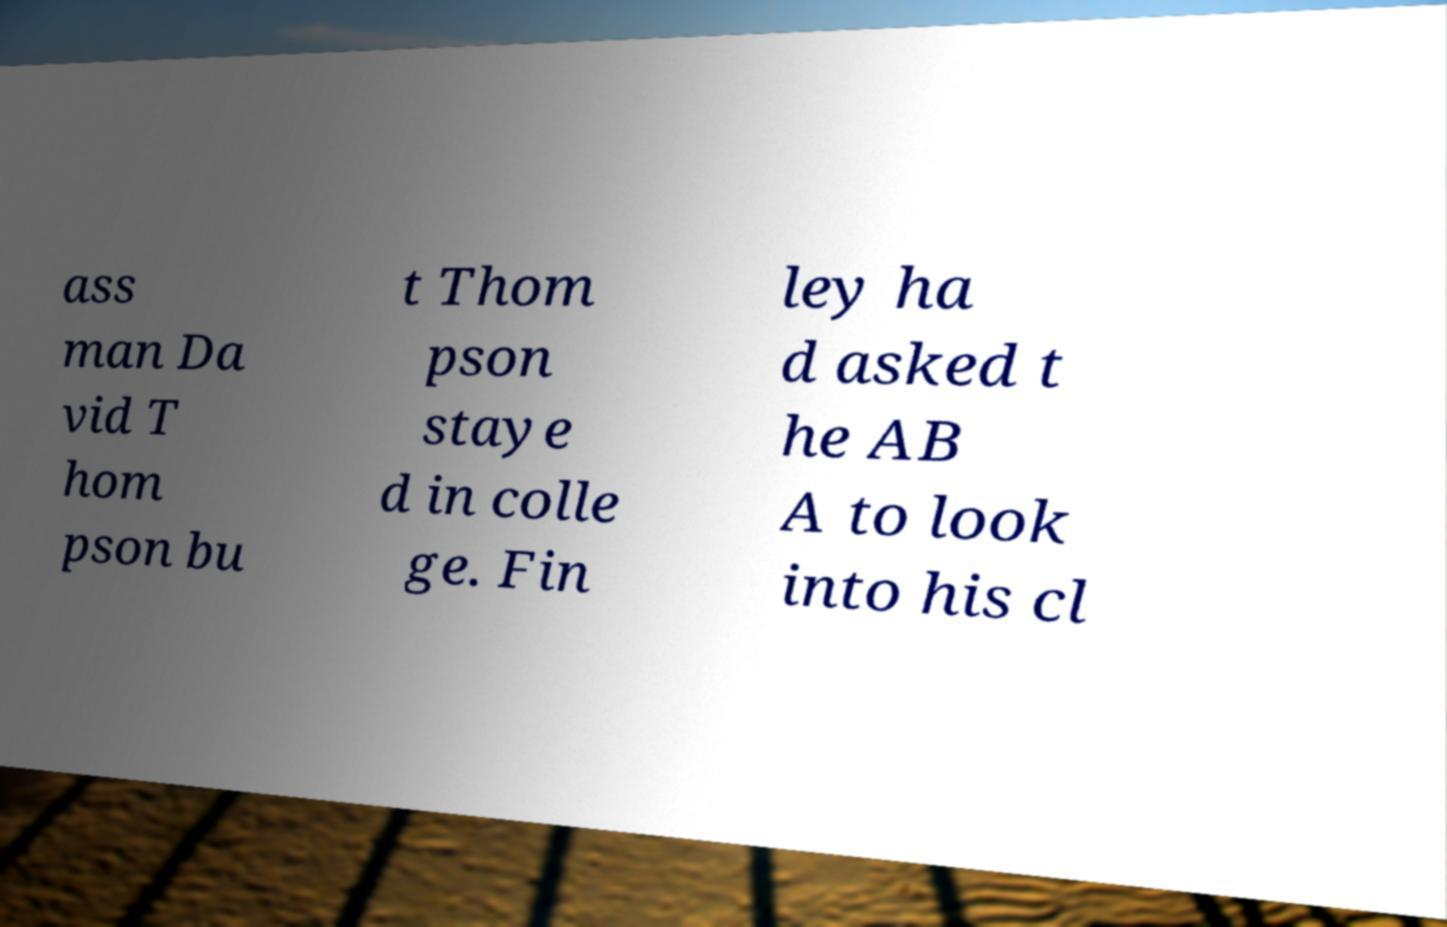I need the written content from this picture converted into text. Can you do that? ass man Da vid T hom pson bu t Thom pson staye d in colle ge. Fin ley ha d asked t he AB A to look into his cl 